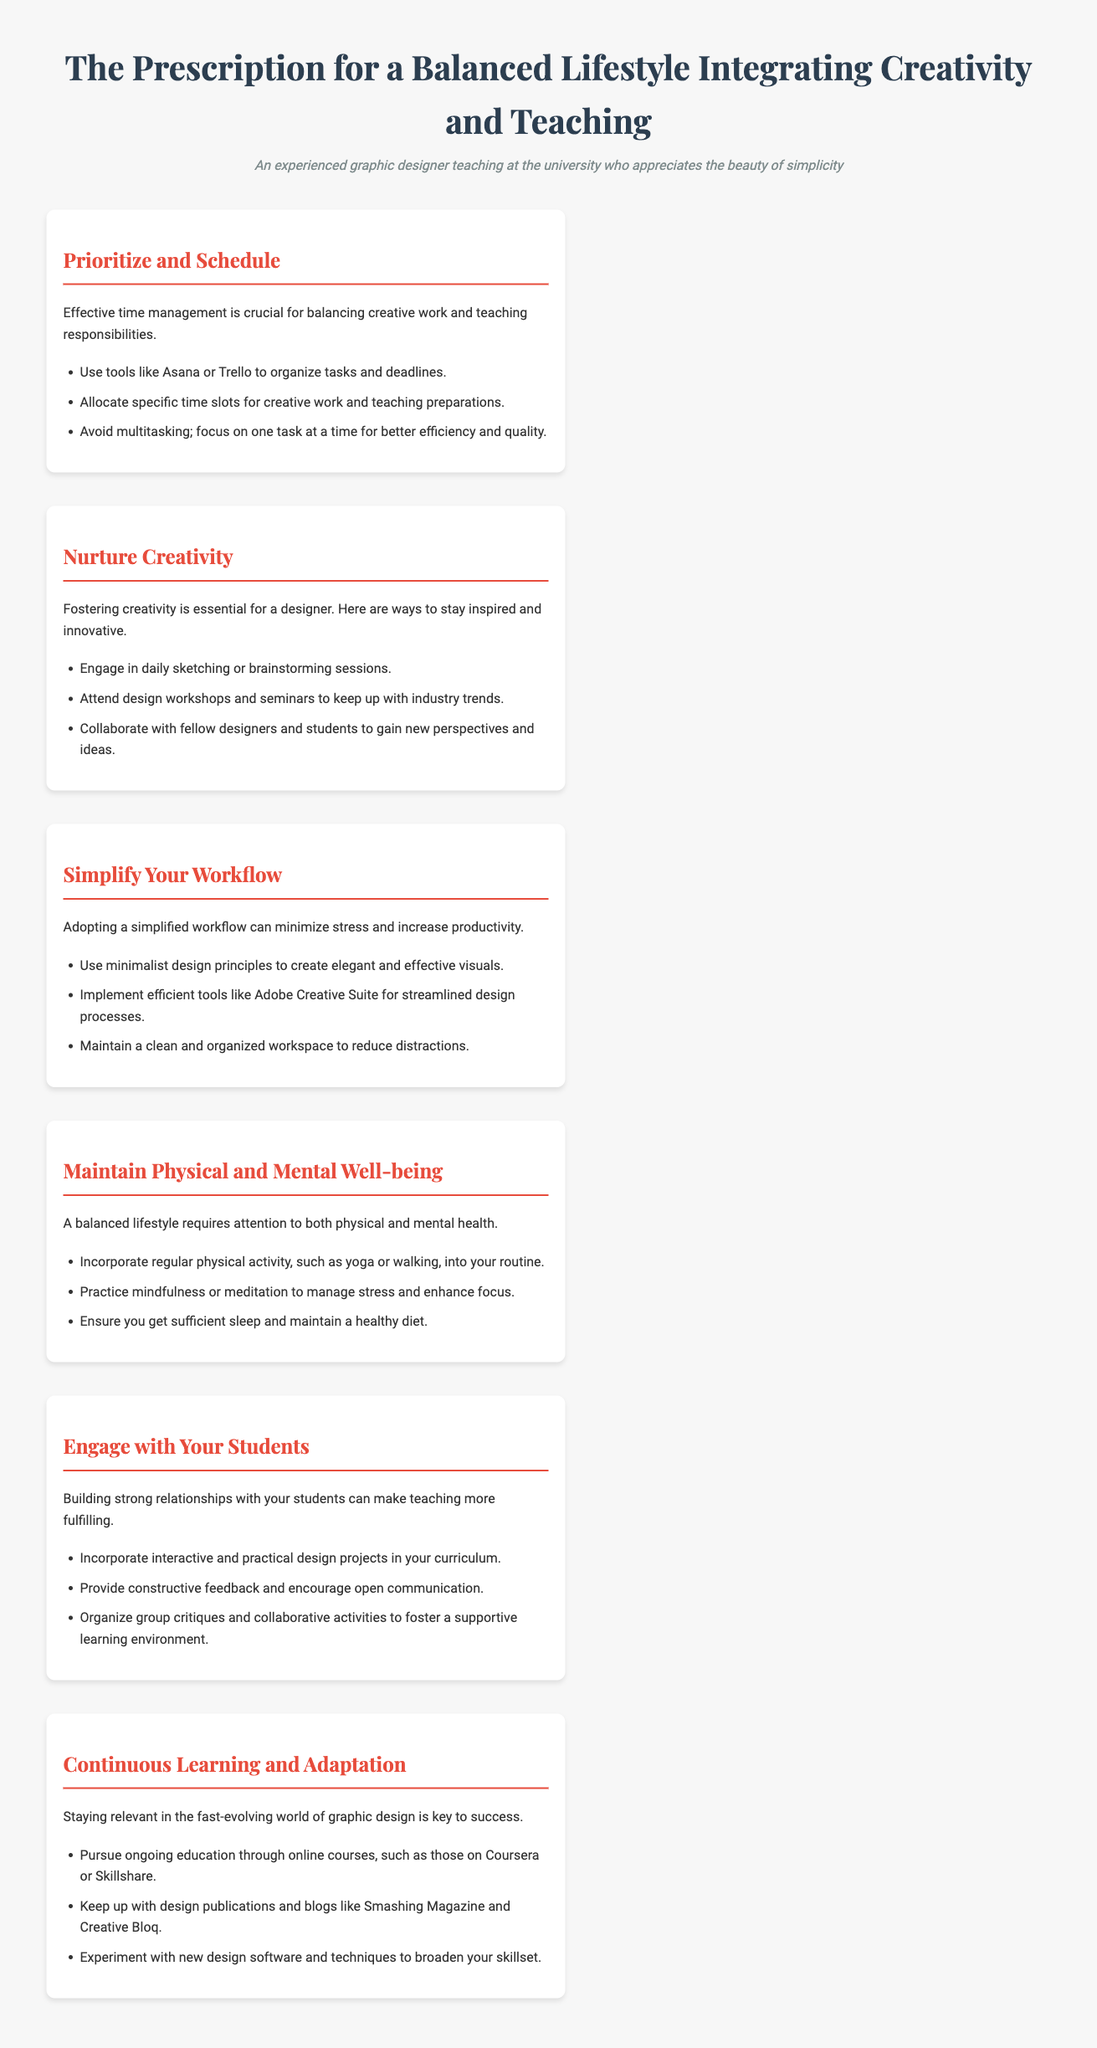What is the title of the document? The title is presented prominently at the top of the document.
Answer: The Prescription for a Balanced Lifestyle Integrating Creativity and Teaching What is the first section about? The first section provides guidance on managing time effectively.
Answer: Prioritize and Schedule How many ways are suggested to nurture creativity? The number of ways can be counted in the list provided under that section.
Answer: Three What is one physical activity recommended for maintaining well-being? The document lists physical activities to support health.
Answer: Yoga What is emphasized for engaging with students? Specific practices to connect with students are outlined in the section.
Answer: Interactive projects What type of design principles does the document suggest using? The document encourages using principles that lead to minimalism in design.
Answer: Minimalist design principles What is a recommended source for continuous education? The document mentions platforms for ongoing education in graphic design.
Answer: Coursera How should workspace be maintained according to the prescription? The document gives advice on workspace organization for better focus.
Answer: Clean and organized 